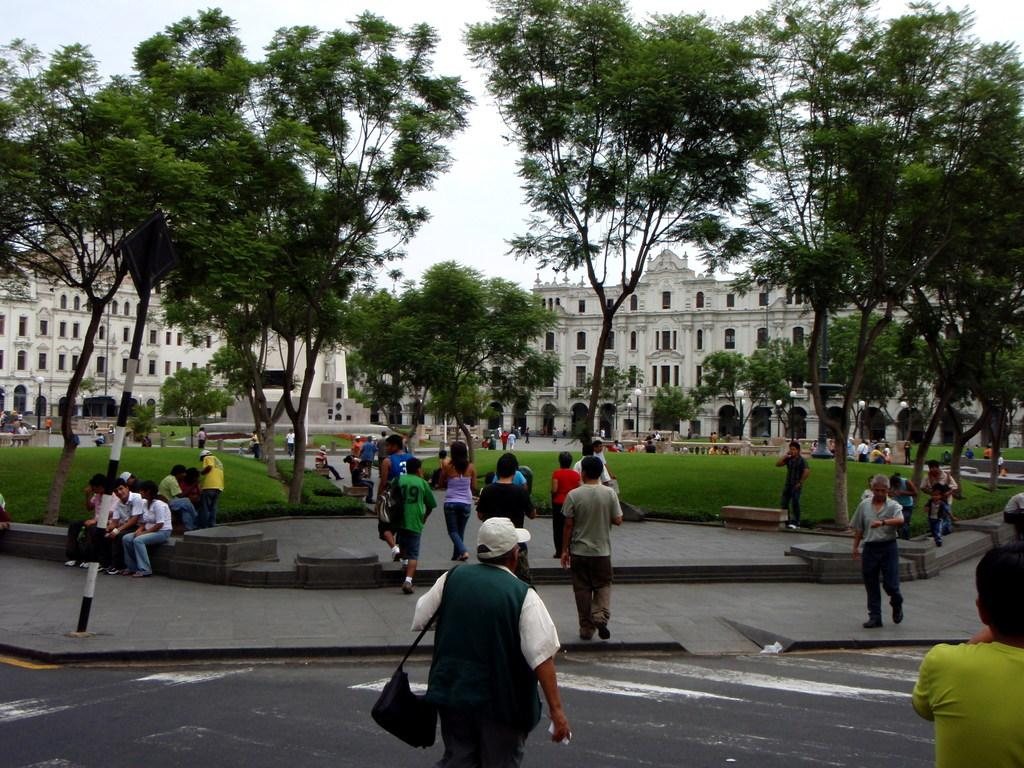What is located at the bottom of the image? There is a group of people at the bottom of the image. What can be seen in the middle of the image? There are trees in the middle of the image. What type of structures are visible in the background of the image? There are buildings in the background of the image. What is visible at the top of the image? The sky is visible at the top of the image. What kind of trouble did the group of people discover while feeling the trees in the image? There is no indication of trouble or feelings in the image; it simply shows a group of people, trees, buildings, and the sky. 